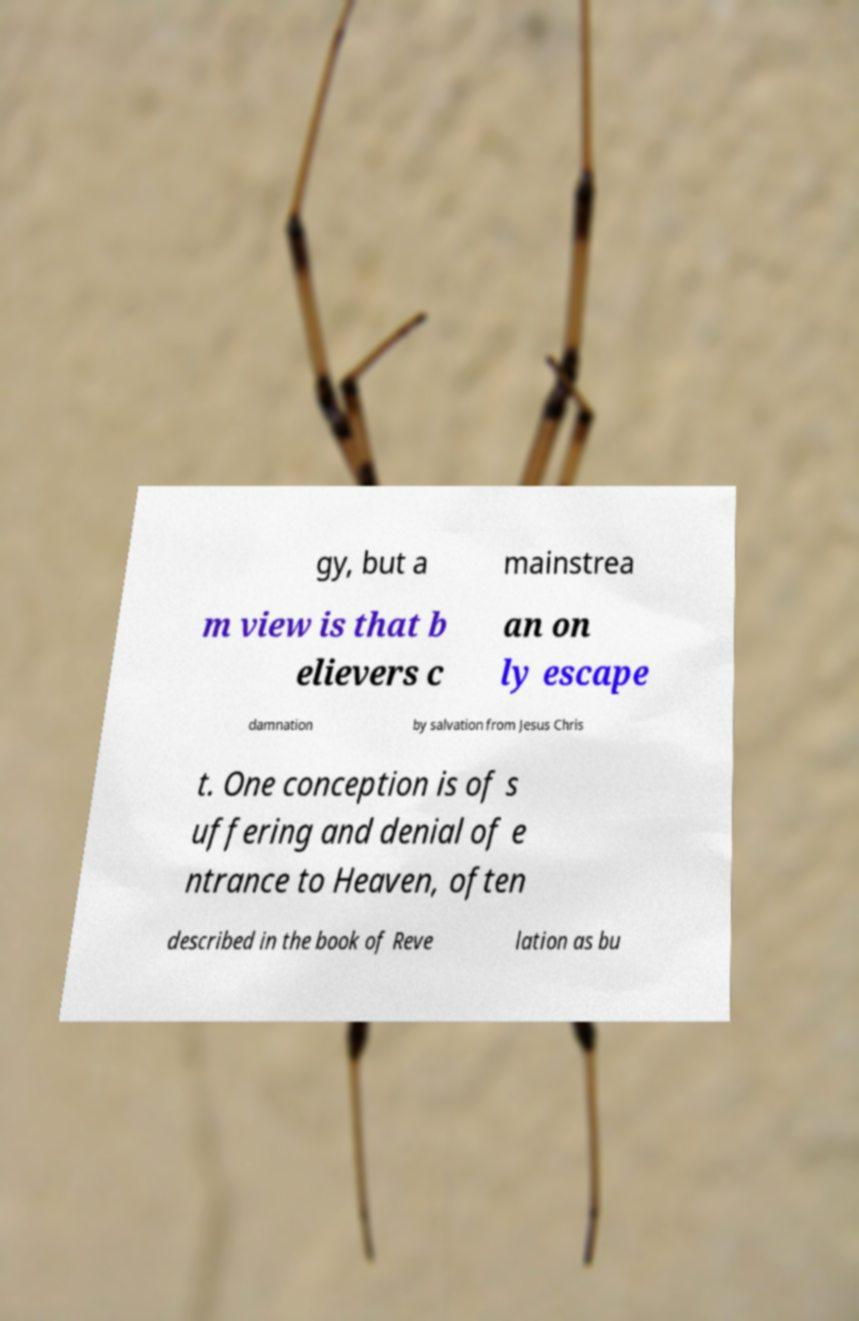There's text embedded in this image that I need extracted. Can you transcribe it verbatim? gy, but a mainstrea m view is that b elievers c an on ly escape damnation by salvation from Jesus Chris t. One conception is of s uffering and denial of e ntrance to Heaven, often described in the book of Reve lation as bu 